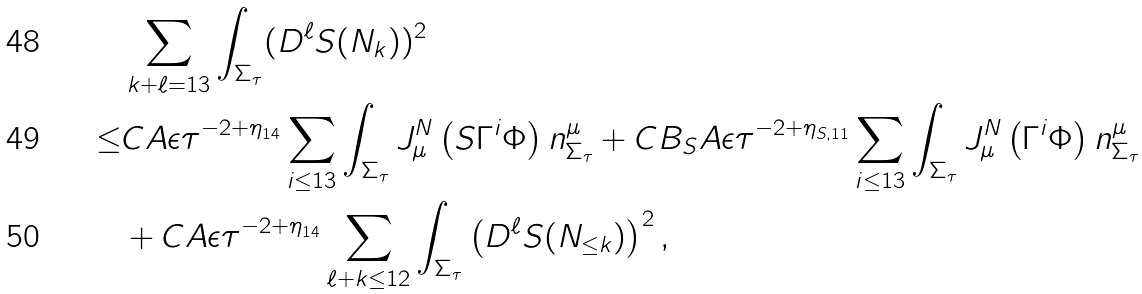Convert formula to latex. <formula><loc_0><loc_0><loc_500><loc_500>& \sum _ { k + \ell = 1 3 } \int _ { \Sigma _ { \tau } } ( D ^ { \ell } S ( N _ { k } ) ) ^ { 2 } \\ \leq & C A \epsilon \tau ^ { - 2 + \eta _ { 1 4 } } \sum _ { i \leq 1 3 } \int _ { \Sigma _ { \tau } } J ^ { N } _ { \mu } \left ( S \Gamma ^ { i } \Phi \right ) n ^ { \mu } _ { \Sigma _ { \tau } } + C B _ { S } A \epsilon \tau ^ { - 2 + \eta _ { S , 1 1 } } \sum _ { i \leq 1 3 } \int _ { \Sigma _ { \tau } } J ^ { N } _ { \mu } \left ( \Gamma ^ { i } \Phi \right ) n ^ { \mu } _ { \Sigma _ { \tau } } \\ & + C A \epsilon \tau ^ { - 2 + \eta _ { 1 4 } } \sum _ { \ell + k \leq 1 2 } \int _ { \Sigma _ { \tau } } \left ( D ^ { \ell } S ( N _ { \leq k } ) \right ) ^ { 2 } ,</formula> 